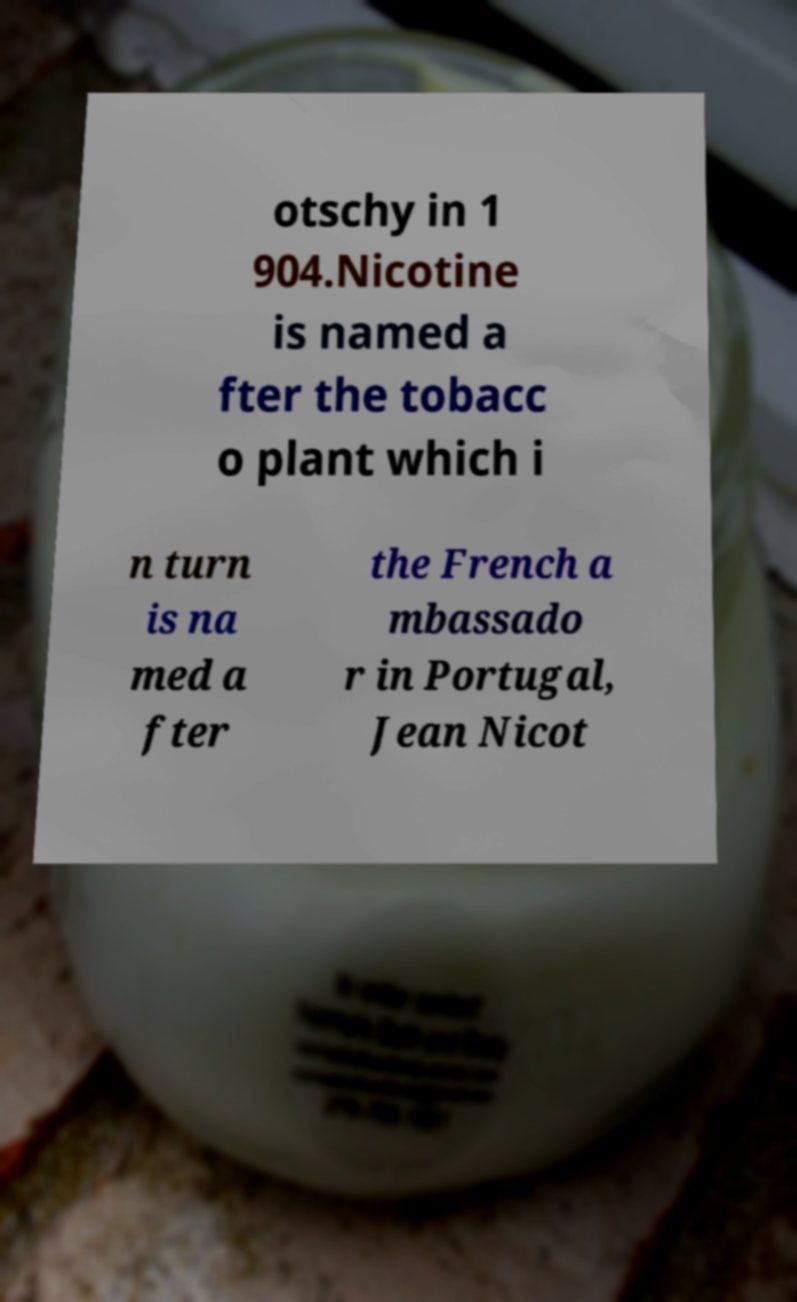For documentation purposes, I need the text within this image transcribed. Could you provide that? otschy in 1 904.Nicotine is named a fter the tobacc o plant which i n turn is na med a fter the French a mbassado r in Portugal, Jean Nicot 